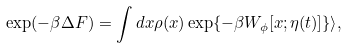<formula> <loc_0><loc_0><loc_500><loc_500>\exp ( - \beta \Delta F ) = \int d x \rho ( x ) \exp \{ - \beta W _ { \phi } [ x ; \eta ( t ) ] \} \rangle ,</formula> 